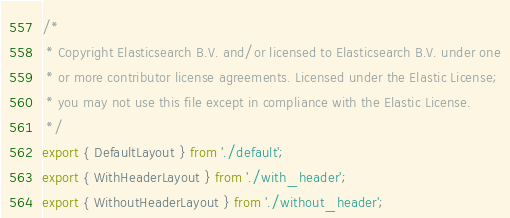<code> <loc_0><loc_0><loc_500><loc_500><_TypeScript_>/*
 * Copyright Elasticsearch B.V. and/or licensed to Elasticsearch B.V. under one
 * or more contributor license agreements. Licensed under the Elastic License;
 * you may not use this file except in compliance with the Elastic License.
 */
export { DefaultLayout } from './default';
export { WithHeaderLayout } from './with_header';
export { WithoutHeaderLayout } from './without_header';
</code> 